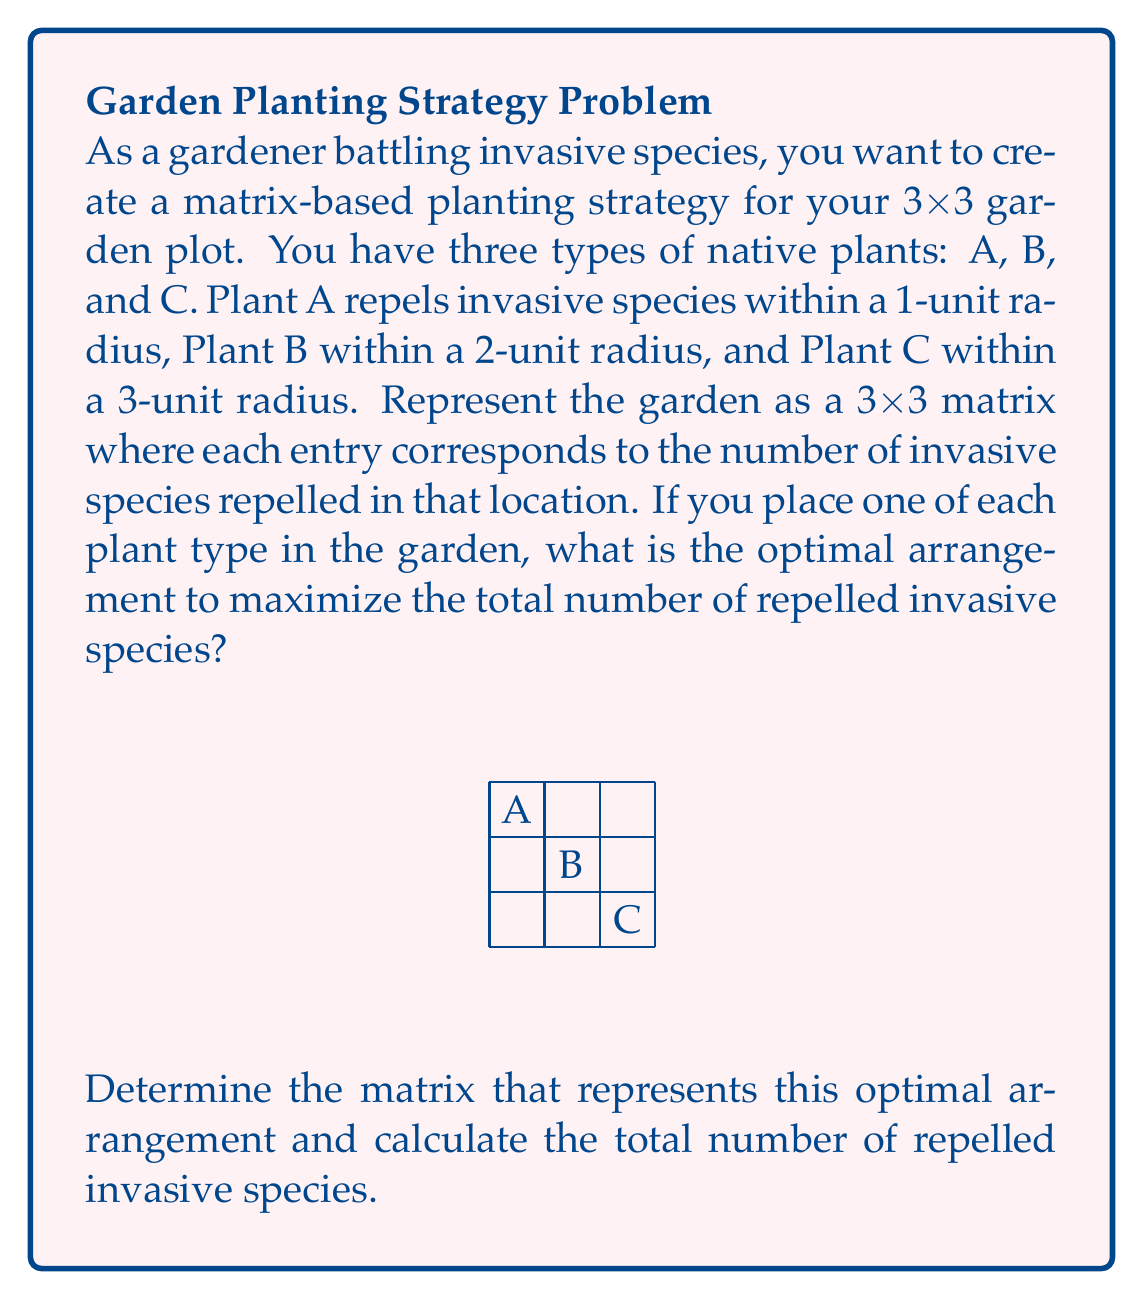Solve this math problem. Let's approach this step-by-step:

1) First, we need to understand how each plant affects the garden:
   - Plant A: Affects its own cell and adjacent cells (1-unit radius)
   - Plant B: Affects its own cell and cells within a 2-unit radius
   - Plant C: Affects all cells in the 3x3 garden (3-unit radius)

2) Let's represent the effect of each plant as a matrix:

   Plant A: $$A = \begin{bmatrix}
   1 & 1 & 0 \\
   1 & 1 & 1 \\
   0 & 1 & 0
   \end{bmatrix}$$

   Plant B: $$B = \begin{bmatrix}
   1 & 1 & 1 \\
   1 & 1 & 1 \\
   1 & 1 & 1
   \end{bmatrix}$$

   Plant C: $$C = \begin{bmatrix}
   1 & 1 & 1 \\
   1 & 1 & 1 \\
   1 & 1 & 1
   \end{bmatrix}$$

3) The optimal arrangement would place:
   - Plant A in a corner (to maximize its effect)
   - Plant B in the center (to cover the entire garden)
   - Plant C in the opposite corner from A (though its position doesn't matter as it affects all cells)

4) This arrangement can be represented as:

   $$\begin{bmatrix}
   A & 0 & 0 \\
   0 & B & 0 \\
   0 & 0 & C
   \end{bmatrix}$$

5) To calculate the total effect, we sum these matrices:

   $$\begin{bmatrix}
   1 & 1 & 0 \\
   1 & 1 & 1 \\
   0 & 1 & 0
   \end{bmatrix} + 
   \begin{bmatrix}
   1 & 1 & 1 \\
   1 & 1 & 1 \\
   1 & 1 & 1
   \end{bmatrix} + 
   \begin{bmatrix}
   1 & 1 & 1 \\
   1 & 1 & 1 \\
   1 & 1 & 1
   \end{bmatrix}$$

6) This results in:

   $$\begin{bmatrix}
   3 & 3 & 2 \\
   3 & 3 & 3 \\
   2 & 3 & 2
   \end{bmatrix}$$

7) The total number of repelled invasive species is the sum of all elements in this matrix: 3 + 3 + 2 + 3 + 3 + 3 + 2 + 3 + 2 = 24
Answer: $$\begin{bmatrix}
3 & 3 & 2 \\
3 & 3 & 3 \\
2 & 3 & 2
\end{bmatrix}$$, 24 repelled invasive species 